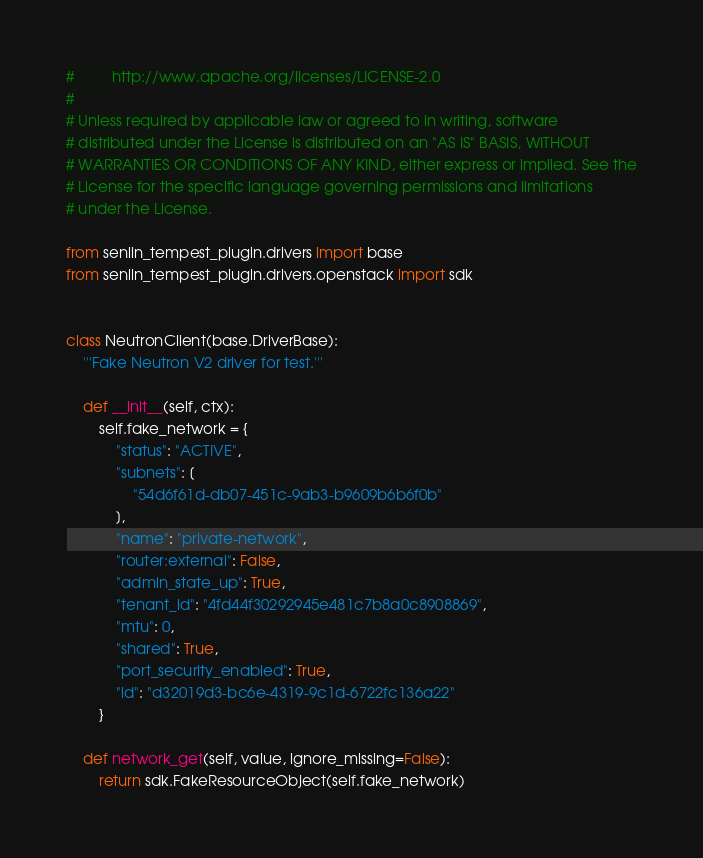<code> <loc_0><loc_0><loc_500><loc_500><_Python_>#         http://www.apache.org/licenses/LICENSE-2.0
#
# Unless required by applicable law or agreed to in writing, software
# distributed under the License is distributed on an "AS IS" BASIS, WITHOUT
# WARRANTIES OR CONDITIONS OF ANY KIND, either express or implied. See the
# License for the specific language governing permissions and limitations
# under the License.

from senlin_tempest_plugin.drivers import base
from senlin_tempest_plugin.drivers.openstack import sdk


class NeutronClient(base.DriverBase):
    '''Fake Neutron V2 driver for test.'''

    def __init__(self, ctx):
        self.fake_network = {
            "status": "ACTIVE",
            "subnets": [
                "54d6f61d-db07-451c-9ab3-b9609b6b6f0b"
            ],
            "name": "private-network",
            "router:external": False,
            "admin_state_up": True,
            "tenant_id": "4fd44f30292945e481c7b8a0c8908869",
            "mtu": 0,
            "shared": True,
            "port_security_enabled": True,
            "id": "d32019d3-bc6e-4319-9c1d-6722fc136a22"
        }

    def network_get(self, value, ignore_missing=False):
        return sdk.FakeResourceObject(self.fake_network)
</code> 